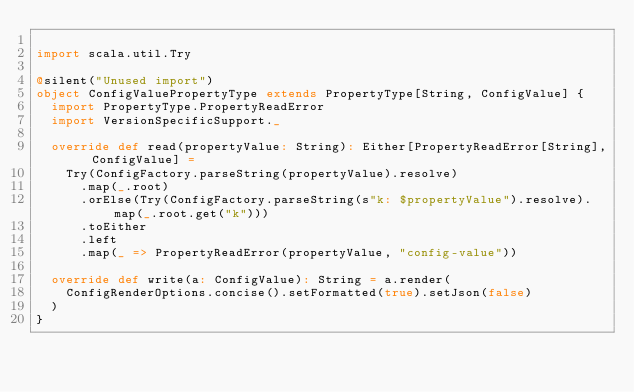<code> <loc_0><loc_0><loc_500><loc_500><_Scala_>
import scala.util.Try

@silent("Unused import")
object ConfigValuePropertyType extends PropertyType[String, ConfigValue] {
  import PropertyType.PropertyReadError
  import VersionSpecificSupport._

  override def read(propertyValue: String): Either[PropertyReadError[String], ConfigValue] =
    Try(ConfigFactory.parseString(propertyValue).resolve)
      .map(_.root)
      .orElse(Try(ConfigFactory.parseString(s"k: $propertyValue").resolve).map(_.root.get("k")))
      .toEither
      .left
      .map(_ => PropertyReadError(propertyValue, "config-value"))

  override def write(a: ConfigValue): String = a.render(
    ConfigRenderOptions.concise().setFormatted(true).setJson(false)
  )
}
</code> 